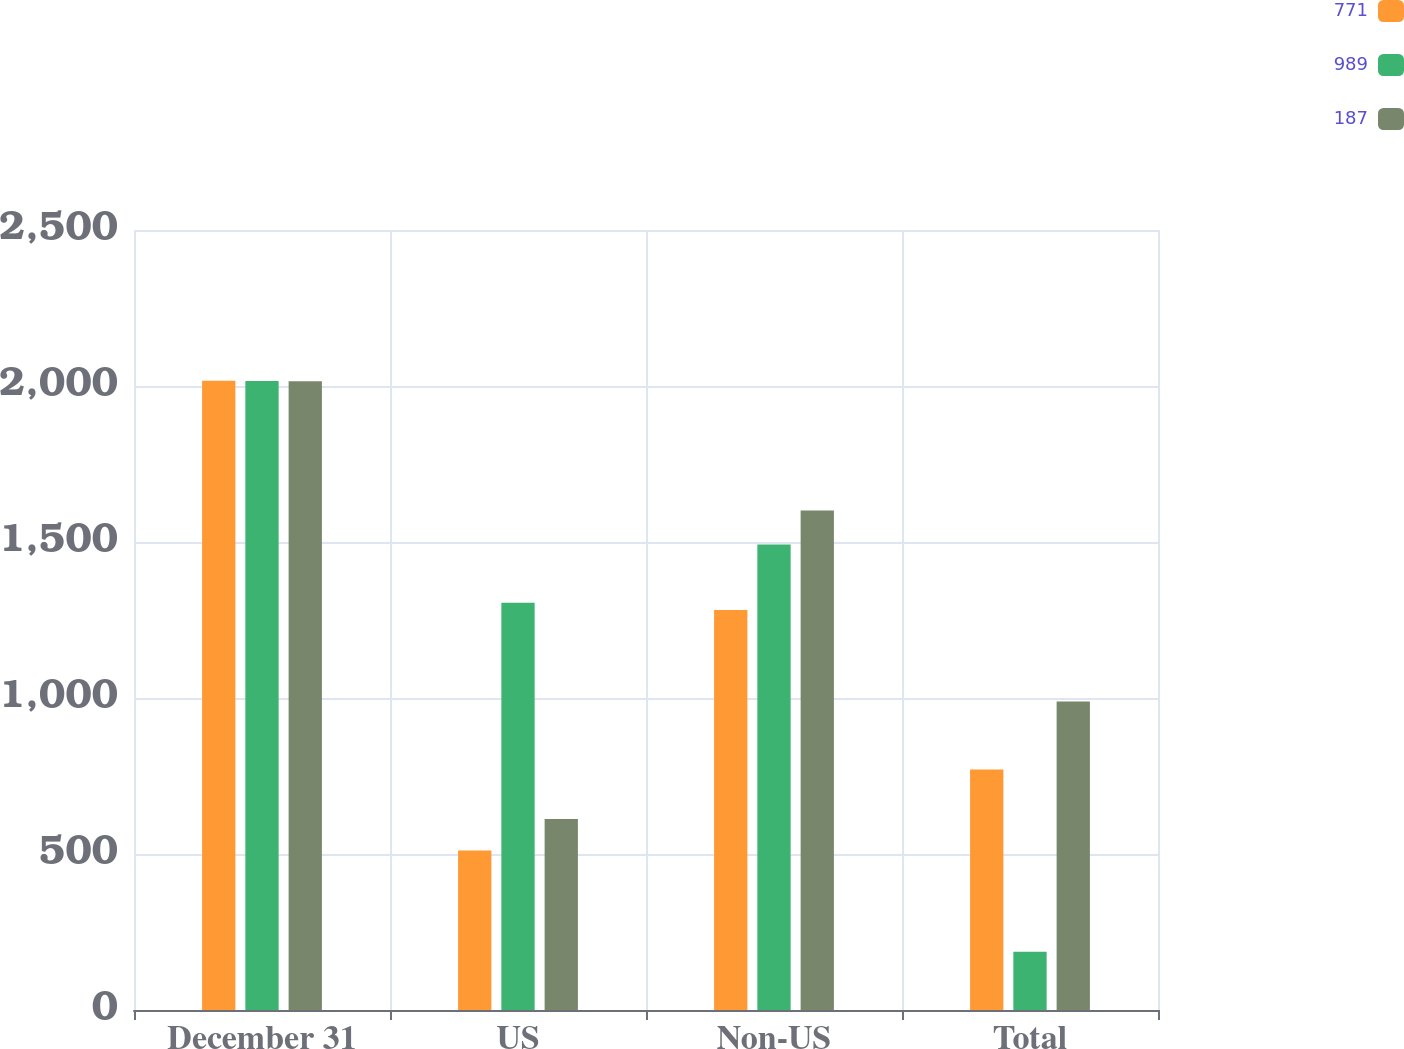Convert chart. <chart><loc_0><loc_0><loc_500><loc_500><stacked_bar_chart><ecel><fcel>December 31<fcel>US<fcel>Non-US<fcel>Total<nl><fcel>771<fcel>2017<fcel>511<fcel>1282<fcel>771<nl><fcel>989<fcel>2016<fcel>1305<fcel>1492<fcel>187<nl><fcel>187<fcel>2015<fcel>612<fcel>1601<fcel>989<nl></chart> 